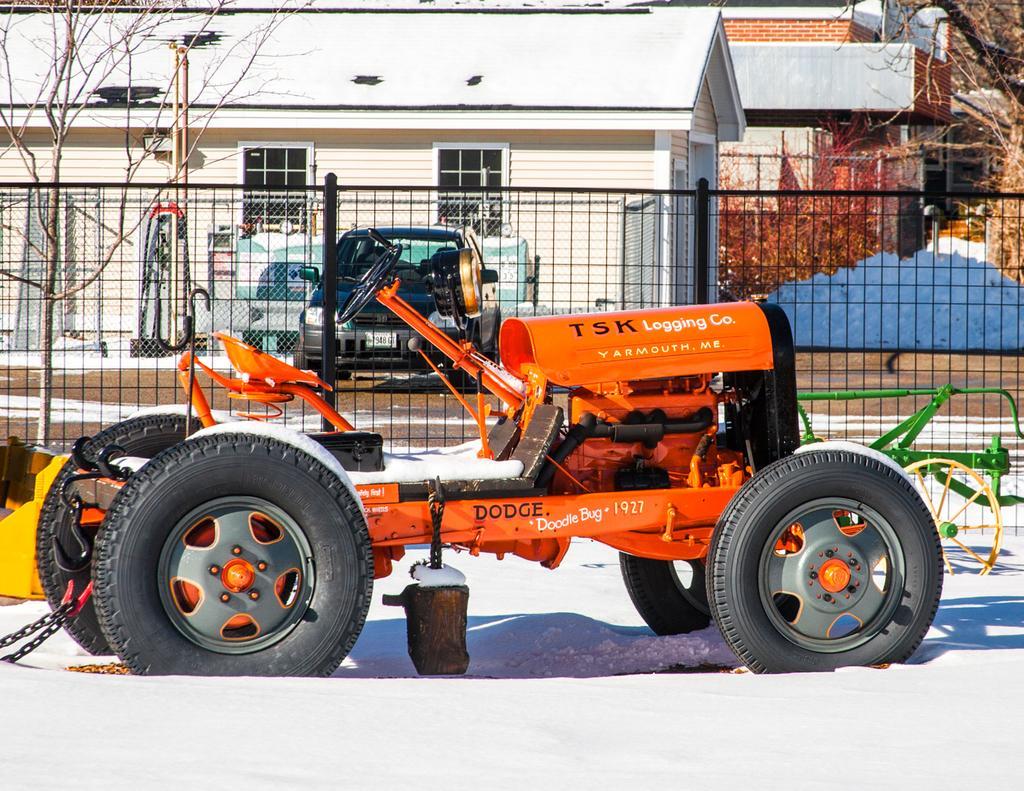In one or two sentences, can you explain what this image depicts? In this image, It looks like a tractor with the wheels, which is on the snow. I think this is the fence. In the background, I can see the houses with the windows. It looks like a car, which is behind the fence. On the left and right side of the image, I can see the trees. 